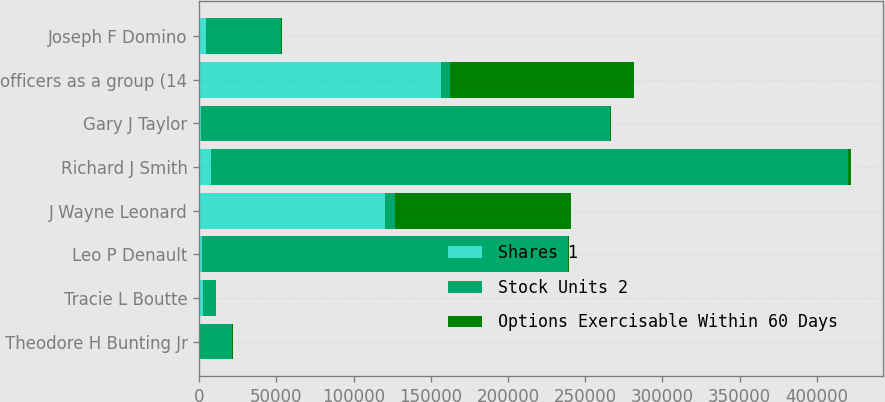Convert chart to OTSL. <chart><loc_0><loc_0><loc_500><loc_500><stacked_bar_chart><ecel><fcel>Theodore H Bunting Jr<fcel>Tracie L Boutte<fcel>Leo P Denault<fcel>J Wayne Leonard<fcel>Richard J Smith<fcel>Gary J Taylor<fcel>officers as a group (14<fcel>Joseph F Domino<nl><fcel>Shares 1<fcel>595<fcel>2220<fcel>1531<fcel>120453<fcel>7753<fcel>1339<fcel>156458<fcel>4651<nl><fcel>Stock Units 2<fcel>20867<fcel>8933<fcel>237357<fcel>6202<fcel>412472<fcel>264834<fcel>6202<fcel>48333<nl><fcel>Options Exercisable Within 60 Days<fcel>128<fcel>7<fcel>753<fcel>113977<fcel>1813<fcel>512<fcel>119050<fcel>357<nl></chart> 